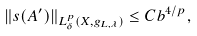<formula> <loc_0><loc_0><loc_500><loc_500>\| s ( A ^ { \prime } ) \| _ { L ^ { p } _ { \delta } ( X , g _ { L , \lambda } ) } \leq C b ^ { 4 / p } ,</formula> 